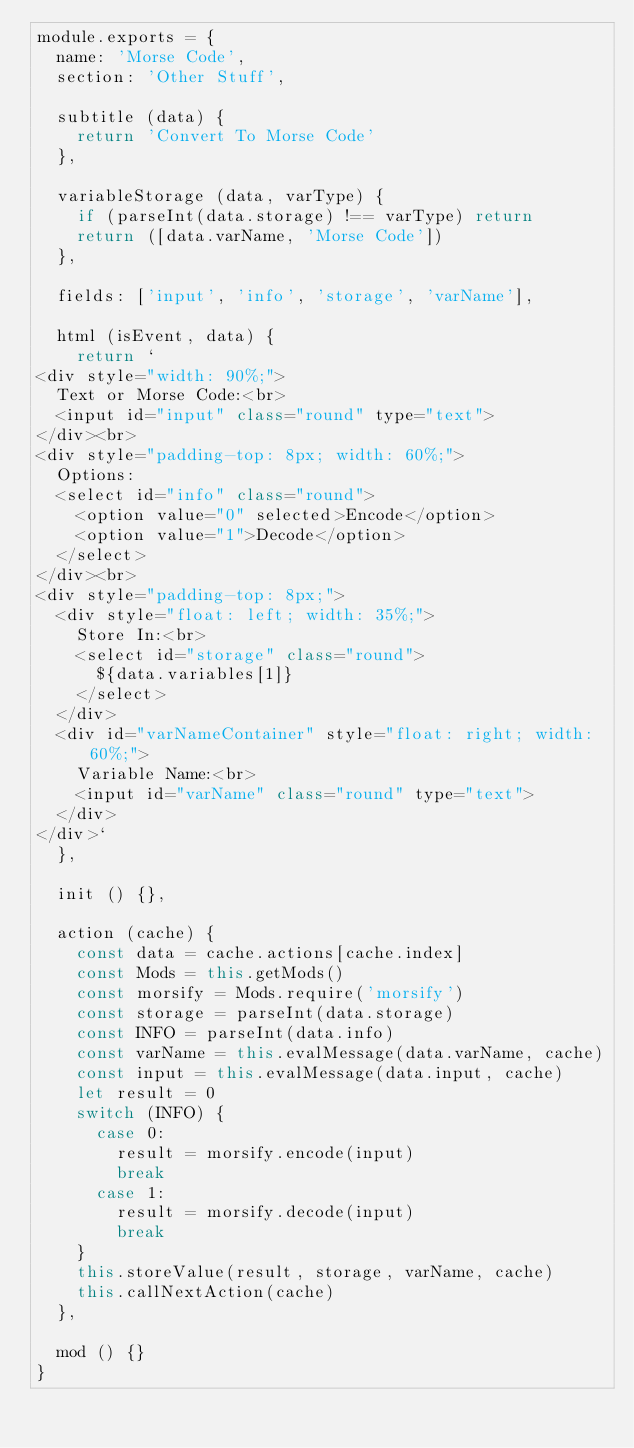<code> <loc_0><loc_0><loc_500><loc_500><_JavaScript_>module.exports = {
  name: 'Morse Code',
  section: 'Other Stuff',

  subtitle (data) {
    return 'Convert To Morse Code'
  },

  variableStorage (data, varType) {
    if (parseInt(data.storage) !== varType) return
    return ([data.varName, 'Morse Code'])
  },

  fields: ['input', 'info', 'storage', 'varName'],

  html (isEvent, data) {
    return `
<div style="width: 90%;">
  Text or Morse Code:<br>
  <input id="input" class="round" type="text">
</div><br>
<div style="padding-top: 8px; width: 60%;">
  Options:
  <select id="info" class="round">
    <option value="0" selected>Encode</option>
    <option value="1">Decode</option>
  </select>
</div><br>
<div style="padding-top: 8px;">
  <div style="float: left; width: 35%;">
    Store In:<br>
    <select id="storage" class="round">
      ${data.variables[1]}
    </select>
  </div>
  <div id="varNameContainer" style="float: right; width: 60%;">
    Variable Name:<br>
    <input id="varName" class="round" type="text">
  </div>
</div>`
  },

  init () {},

  action (cache) {
    const data = cache.actions[cache.index]
    const Mods = this.getMods()
    const morsify = Mods.require('morsify')
    const storage = parseInt(data.storage)
    const INFO = parseInt(data.info)
    const varName = this.evalMessage(data.varName, cache)
    const input = this.evalMessage(data.input, cache)
    let result = 0
    switch (INFO) {
      case 0:
        result = morsify.encode(input)
        break
      case 1:
        result = morsify.decode(input)
        break
    }
    this.storeValue(result, storage, varName, cache)
    this.callNextAction(cache)
  },

  mod () {}
}
</code> 